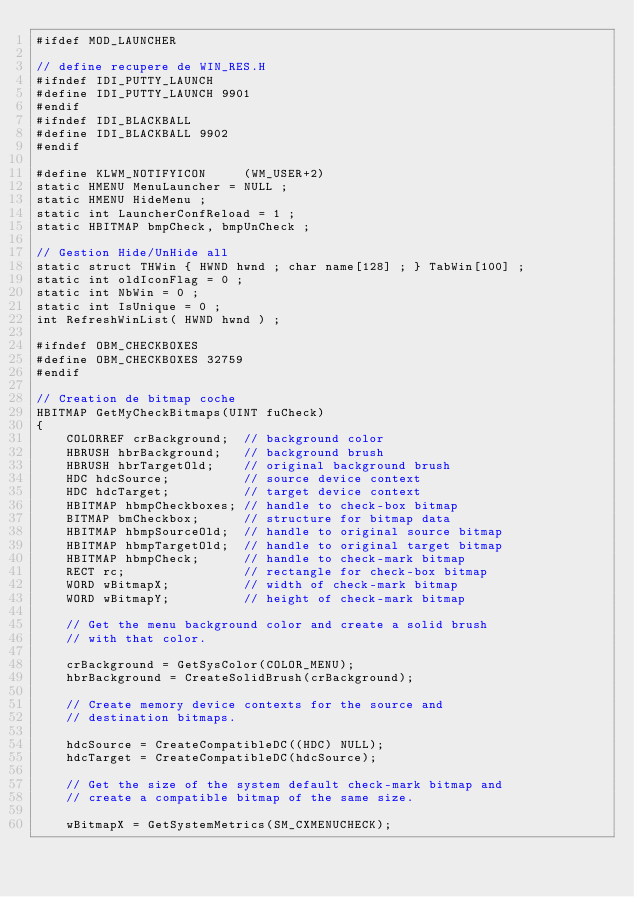<code> <loc_0><loc_0><loc_500><loc_500><_C_>#ifdef MOD_LAUNCHER

// define recupere de WIN_RES.H
#ifndef IDI_PUTTY_LAUNCH
#define IDI_PUTTY_LAUNCH 9901
#endif
#ifndef IDI_BLACKBALL
#define IDI_BLACKBALL 9902
#endif

#define KLWM_NOTIFYICON		(WM_USER+2)
static HMENU MenuLauncher = NULL ;
static HMENU HideMenu ;
static int LauncherConfReload = 1 ;
static HBITMAP bmpCheck, bmpUnCheck ;

// Gestion Hide/UnHide all
static struct THWin { HWND hwnd ; char name[128] ; } TabWin[100] ;
static int oldIconFlag = 0 ;
static int NbWin = 0 ;
static int IsUnique = 0 ;
int RefreshWinList( HWND hwnd ) ;

#ifndef OBM_CHECKBOXES
#define OBM_CHECKBOXES 32759
#endif

// Creation de bitmap coche
HBITMAP GetMyCheckBitmaps(UINT fuCheck) 
{ 
    COLORREF crBackground;  // background color                  
    HBRUSH hbrBackground;   // background brush                  
    HBRUSH hbrTargetOld;    // original background brush         
    HDC hdcSource;          // source device context             
    HDC hdcTarget;          // target device context             
    HBITMAP hbmpCheckboxes; // handle to check-box bitmap        
    BITMAP bmCheckbox;      // structure for bitmap data         
    HBITMAP hbmpSourceOld;  // handle to original source bitmap  
    HBITMAP hbmpTargetOld;  // handle to original target bitmap  
    HBITMAP hbmpCheck;      // handle to check-mark bitmap       
    RECT rc;                // rectangle for check-box bitmap    
    WORD wBitmapX;          // width of check-mark bitmap        
    WORD wBitmapY;          // height of check-mark bitmap       
 
    // Get the menu background color and create a solid brush 
    // with that color. 
 
    crBackground = GetSysColor(COLOR_MENU); 
    hbrBackground = CreateSolidBrush(crBackground); 
 
    // Create memory device contexts for the source and 
    // destination bitmaps. 
 
    hdcSource = CreateCompatibleDC((HDC) NULL); 
    hdcTarget = CreateCompatibleDC(hdcSource); 
 
    // Get the size of the system default check-mark bitmap and 
    // create a compatible bitmap of the same size. 
 
    wBitmapX = GetSystemMetrics(SM_CXMENUCHECK); </code> 